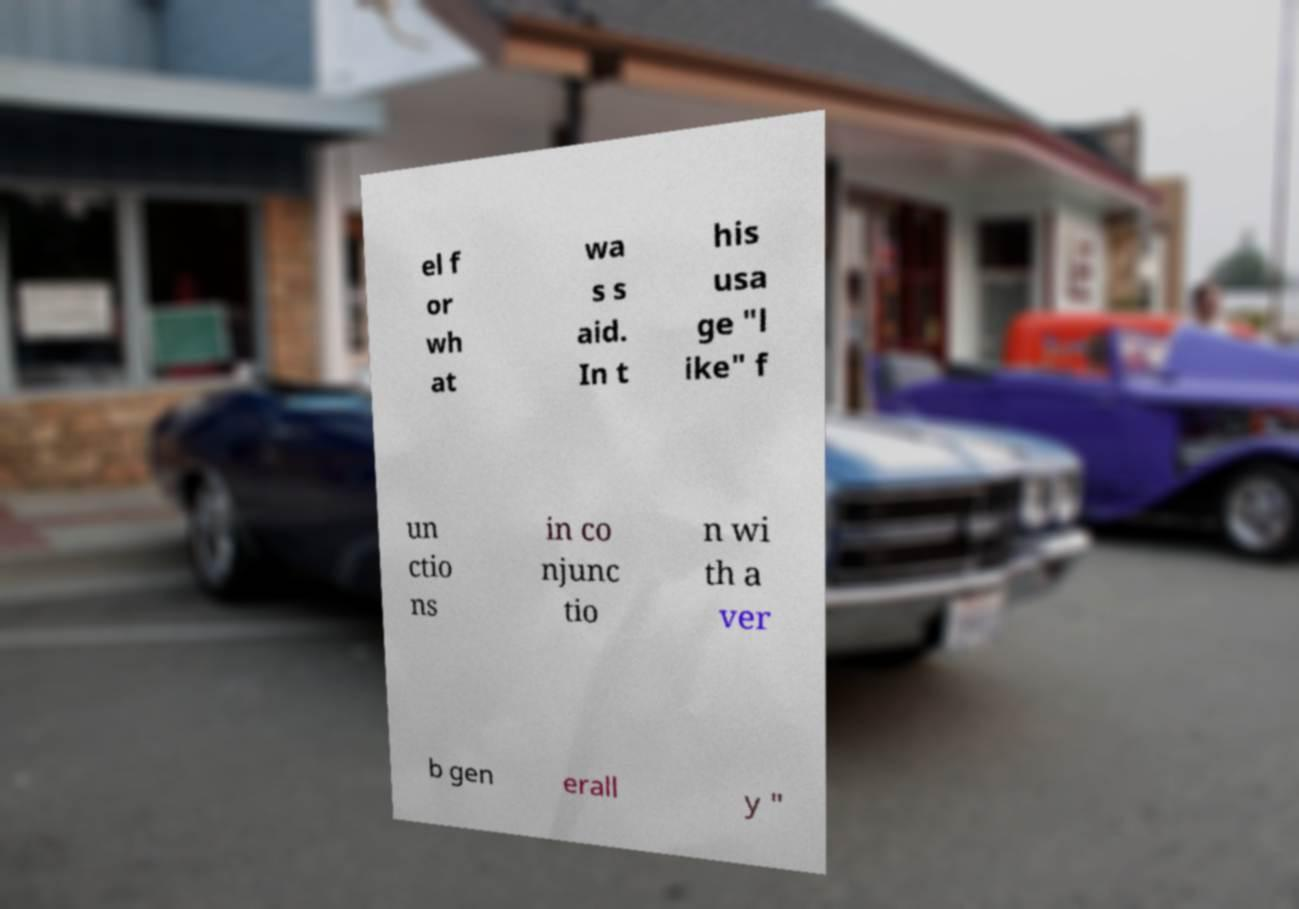Could you extract and type out the text from this image? el f or wh at wa s s aid. In t his usa ge "l ike" f un ctio ns in co njunc tio n wi th a ver b gen erall y " 